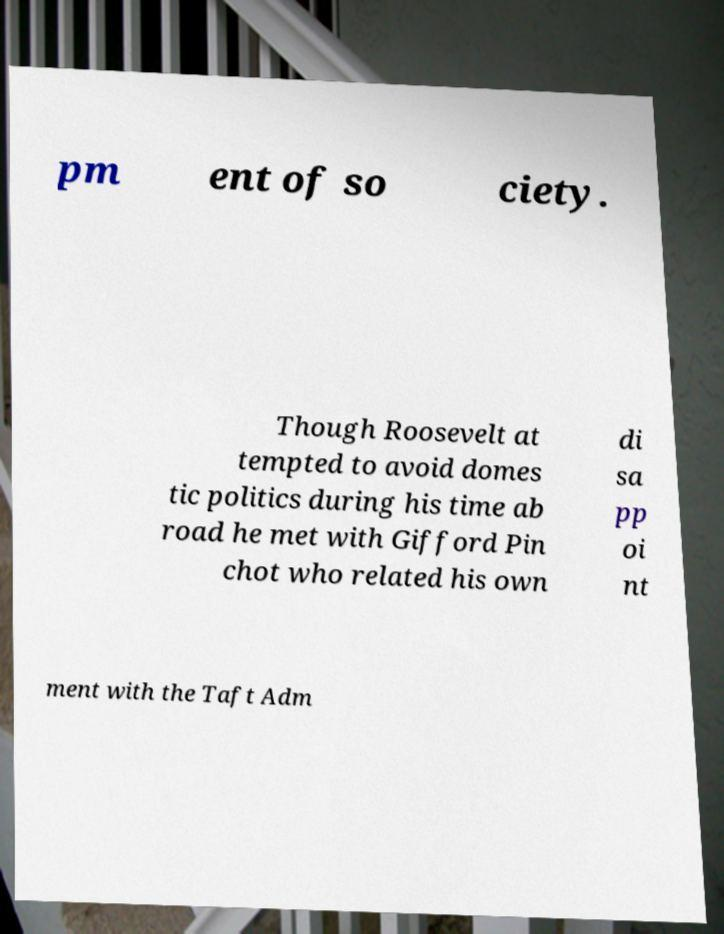I need the written content from this picture converted into text. Can you do that? pm ent of so ciety. Though Roosevelt at tempted to avoid domes tic politics during his time ab road he met with Gifford Pin chot who related his own di sa pp oi nt ment with the Taft Adm 